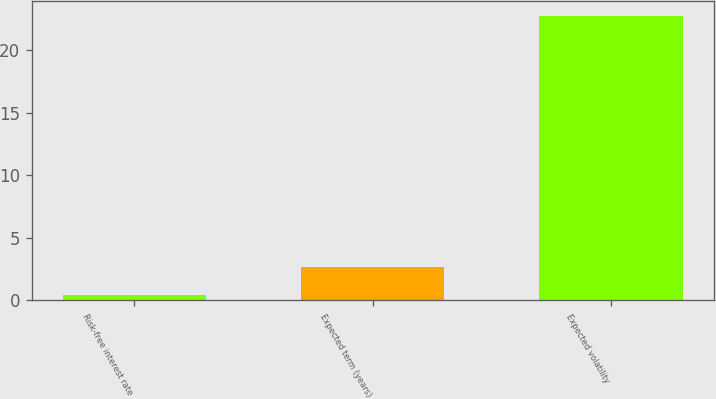<chart> <loc_0><loc_0><loc_500><loc_500><bar_chart><fcel>Risk-free interest rate<fcel>Expected term (years)<fcel>Expected volatility<nl><fcel>0.45<fcel>2.68<fcel>22.77<nl></chart> 